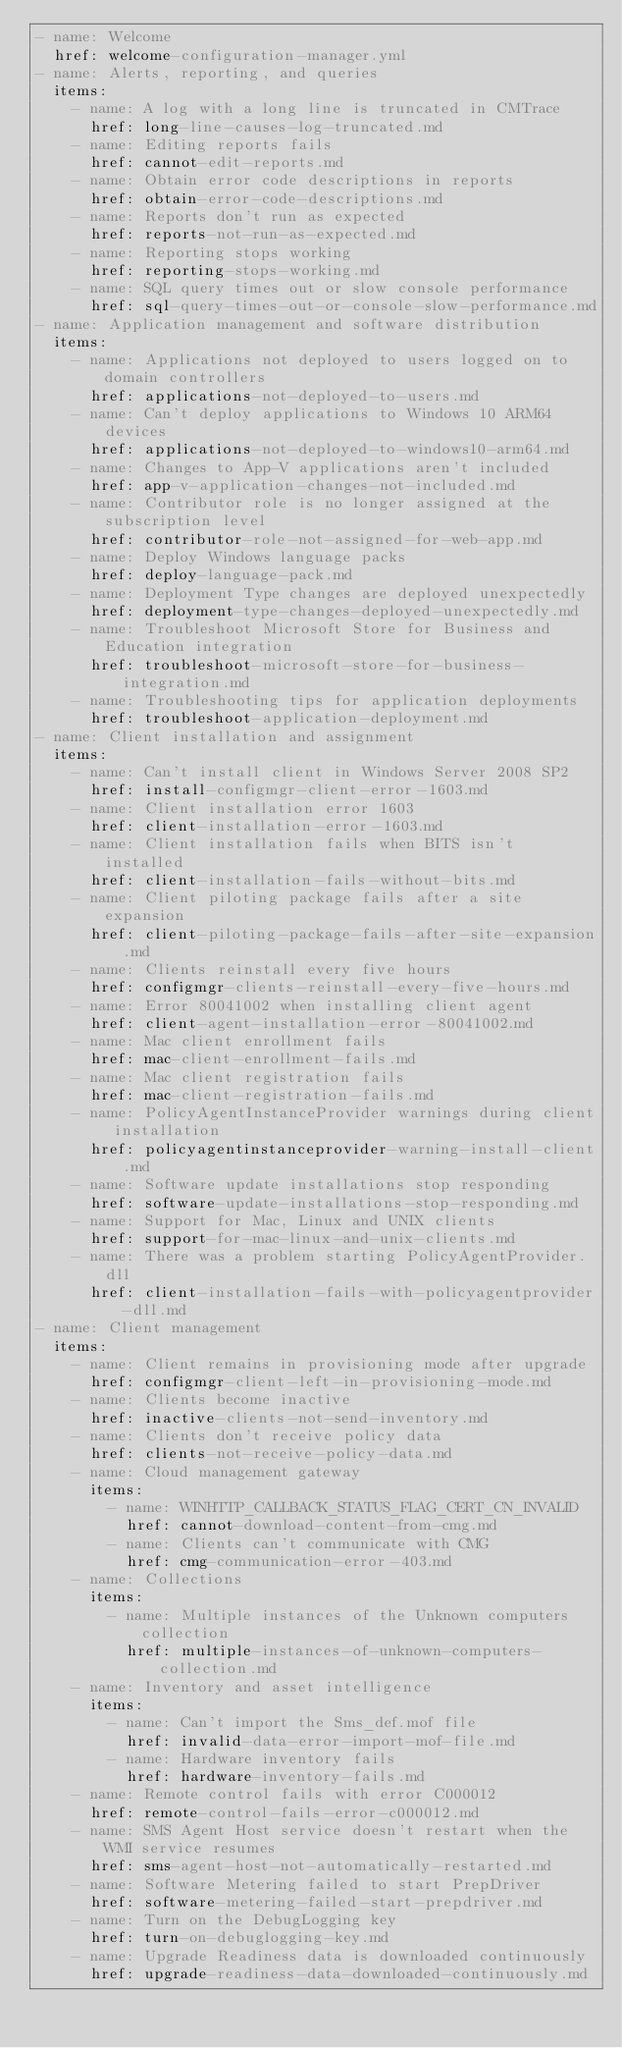<code> <loc_0><loc_0><loc_500><loc_500><_YAML_>- name: Welcome
  href: welcome-configuration-manager.yml
- name: Alerts, reporting, and queries
  items:
    - name: A log with a long line is truncated in CMTrace
      href: long-line-causes-log-truncated.md
    - name: Editing reports fails
      href: cannot-edit-reports.md
    - name: Obtain error code descriptions in reports
      href: obtain-error-code-descriptions.md
    - name: Reports don't run as expected
      href: reports-not-run-as-expected.md
    - name: Reporting stops working
      href: reporting-stops-working.md
    - name: SQL query times out or slow console performance
      href: sql-query-times-out-or-console-slow-performance.md
- name: Application management and software distribution
  items:
    - name: Applications not deployed to users logged on to domain controllers
      href: applications-not-deployed-to-users.md
    - name: Can't deploy applications to Windows 10 ARM64 devices
      href: applications-not-deployed-to-windows10-arm64.md
    - name: Changes to App-V applications aren't included
      href: app-v-application-changes-not-included.md
    - name: Contributor role is no longer assigned at the subscription level
      href: contributor-role-not-assigned-for-web-app.md
    - name: Deploy Windows language packs
      href: deploy-language-pack.md
    - name: Deployment Type changes are deployed unexpectedly
      href: deployment-type-changes-deployed-unexpectedly.md
    - name: Troubleshoot Microsoft Store for Business and Education integration
      href: troubleshoot-microsoft-store-for-business-integration.md
    - name: Troubleshooting tips for application deployments
      href: troubleshoot-application-deployment.md
- name: Client installation and assignment
  items:
    - name: Can't install client in Windows Server 2008 SP2
      href: install-configmgr-client-error-1603.md
    - name: Client installation error 1603
      href: client-installation-error-1603.md
    - name: Client installation fails when BITS isn't installed
      href: client-installation-fails-without-bits.md
    - name: Client piloting package fails after a site expansion
      href: client-piloting-package-fails-after-site-expansion.md
    - name: Clients reinstall every five hours
      href: configmgr-clients-reinstall-every-five-hours.md
    - name: Error 80041002 when installing client agent
      href: client-agent-installation-error-80041002.md
    - name: Mac client enrollment fails
      href: mac-client-enrollment-fails.md
    - name: Mac client registration fails
      href: mac-client-registration-fails.md
    - name: PolicyAgentInstanceProvider warnings during client installation
      href: policyagentinstanceprovider-warning-install-client.md
    - name: Software update installations stop responding
      href: software-update-installations-stop-responding.md
    - name: Support for Mac, Linux and UNIX clients
      href: support-for-mac-linux-and-unix-clients.md
    - name: There was a problem starting PolicyAgentProvider.dll
      href: client-installation-fails-with-policyagentprovider-dll.md
- name: Client management
  items:
    - name: Client remains in provisioning mode after upgrade
      href: configmgr-client-left-in-provisioning-mode.md
    - name: Clients become inactive
      href: inactive-clients-not-send-inventory.md
    - name: Clients don't receive policy data
      href: clients-not-receive-policy-data.md
    - name: Cloud management gateway
      items:
        - name: WINHTTP_CALLBACK_STATUS_FLAG_CERT_CN_INVALID
          href: cannot-download-content-from-cmg.md
        - name: Clients can't communicate with CMG
          href: cmg-communication-error-403.md
    - name: Collections
      items:
        - name: Multiple instances of the Unknown computers collection
          href: multiple-instances-of-unknown-computers-collection.md
    - name: Inventory and asset intelligence
      items:
        - name: Can't import the Sms_def.mof file
          href: invalid-data-error-import-mof-file.md
        - name: Hardware inventory fails
          href: hardware-inventory-fails.md
    - name: Remote control fails with error C000012
      href: remote-control-fails-error-c000012.md
    - name: SMS Agent Host service doesn't restart when the WMI service resumes
      href: sms-agent-host-not-automatically-restarted.md
    - name: Software Metering failed to start PrepDriver
      href: software-metering-failed-start-prepdriver.md
    - name: Turn on the DebugLogging key
      href: turn-on-debuglogging-key.md
    - name: Upgrade Readiness data is downloaded continuously
      href: upgrade-readiness-data-downloaded-continuously.md</code> 